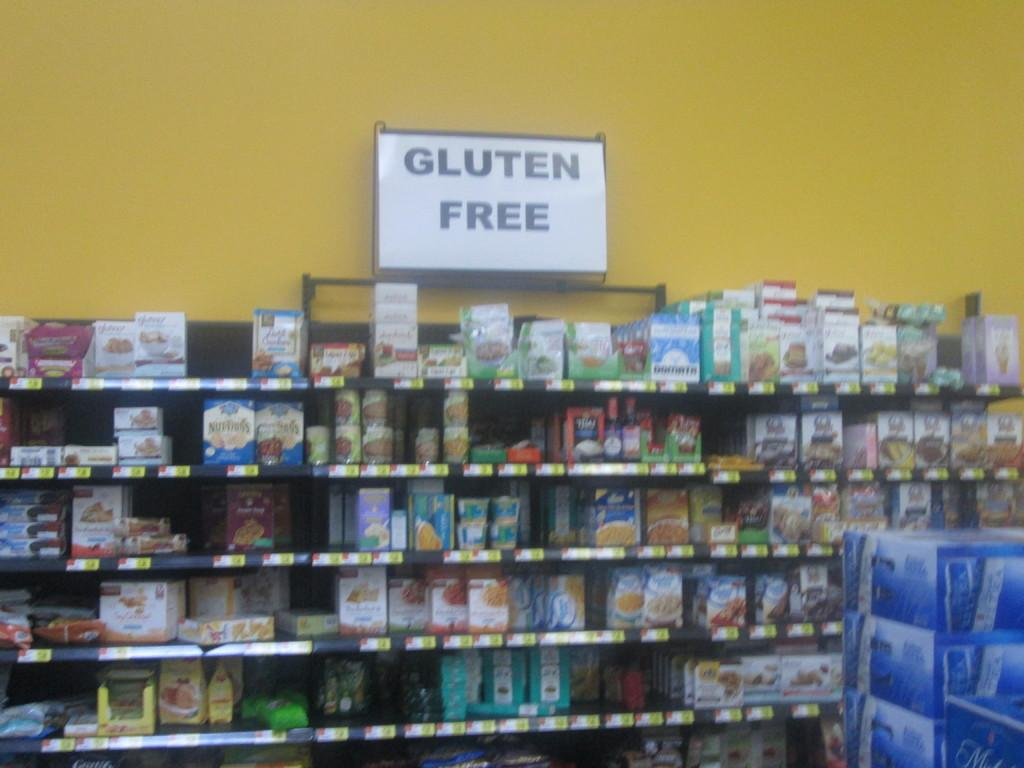<image>
Offer a succinct explanation of the picture presented. a sign above shelves in a room that says 'gluten free' 